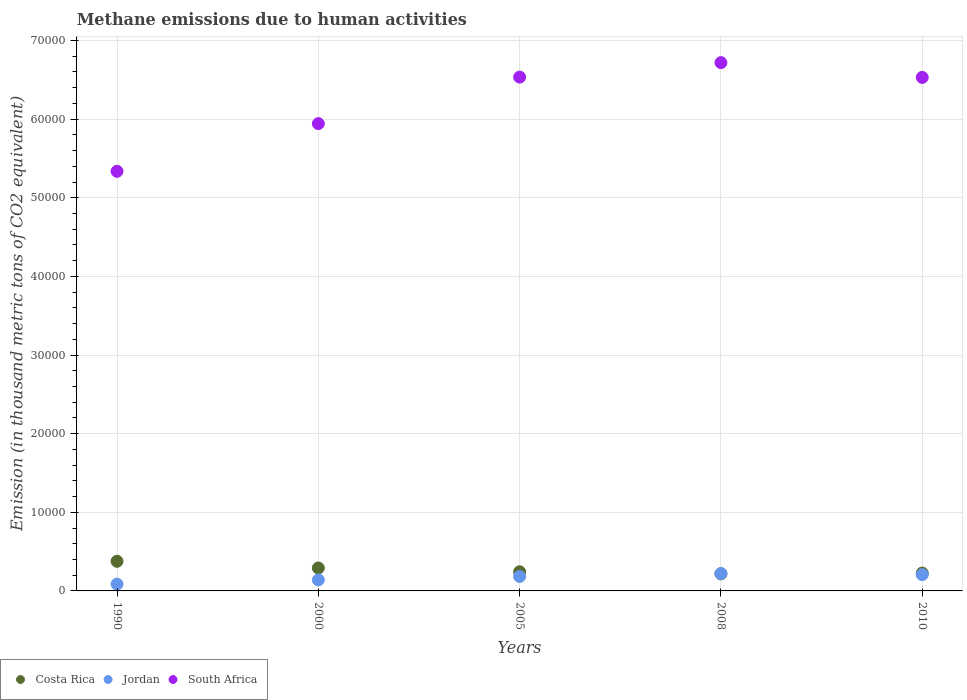How many different coloured dotlines are there?
Give a very brief answer. 3. What is the amount of methane emitted in Jordan in 2000?
Offer a terse response. 1401.8. Across all years, what is the maximum amount of methane emitted in Jordan?
Your answer should be very brief. 2204.6. Across all years, what is the minimum amount of methane emitted in Costa Rica?
Your answer should be compact. 2167.9. In which year was the amount of methane emitted in Jordan maximum?
Your answer should be very brief. 2008. In which year was the amount of methane emitted in Jordan minimum?
Offer a terse response. 1990. What is the total amount of methane emitted in Costa Rica in the graph?
Your answer should be compact. 1.36e+04. What is the difference between the amount of methane emitted in South Africa in 2000 and that in 2010?
Offer a very short reply. -5881.2. What is the difference between the amount of methane emitted in South Africa in 2005 and the amount of methane emitted in Jordan in 2010?
Give a very brief answer. 6.33e+04. What is the average amount of methane emitted in South Africa per year?
Provide a short and direct response. 6.21e+04. In the year 2000, what is the difference between the amount of methane emitted in Costa Rica and amount of methane emitted in Jordan?
Keep it short and to the point. 1515.1. In how many years, is the amount of methane emitted in Costa Rica greater than 68000 thousand metric tons?
Ensure brevity in your answer.  0. What is the ratio of the amount of methane emitted in South Africa in 2000 to that in 2010?
Your response must be concise. 0.91. What is the difference between the highest and the second highest amount of methane emitted in Costa Rica?
Your response must be concise. 851.6. What is the difference between the highest and the lowest amount of methane emitted in South Africa?
Your answer should be very brief. 1.38e+04. In how many years, is the amount of methane emitted in Jordan greater than the average amount of methane emitted in Jordan taken over all years?
Ensure brevity in your answer.  3. Is the sum of the amount of methane emitted in Jordan in 1990 and 2005 greater than the maximum amount of methane emitted in Costa Rica across all years?
Your response must be concise. No. Is the amount of methane emitted in Jordan strictly less than the amount of methane emitted in South Africa over the years?
Your answer should be compact. Yes. How many dotlines are there?
Provide a short and direct response. 3. Does the graph contain any zero values?
Give a very brief answer. No. Does the graph contain grids?
Keep it short and to the point. Yes. What is the title of the graph?
Your answer should be very brief. Methane emissions due to human activities. What is the label or title of the X-axis?
Offer a very short reply. Years. What is the label or title of the Y-axis?
Your answer should be very brief. Emission (in thousand metric tons of CO2 equivalent). What is the Emission (in thousand metric tons of CO2 equivalent) in Costa Rica in 1990?
Ensure brevity in your answer.  3768.5. What is the Emission (in thousand metric tons of CO2 equivalent) of Jordan in 1990?
Keep it short and to the point. 867.1. What is the Emission (in thousand metric tons of CO2 equivalent) in South Africa in 1990?
Provide a short and direct response. 5.34e+04. What is the Emission (in thousand metric tons of CO2 equivalent) in Costa Rica in 2000?
Provide a succinct answer. 2916.9. What is the Emission (in thousand metric tons of CO2 equivalent) of Jordan in 2000?
Ensure brevity in your answer.  1401.8. What is the Emission (in thousand metric tons of CO2 equivalent) of South Africa in 2000?
Your response must be concise. 5.94e+04. What is the Emission (in thousand metric tons of CO2 equivalent) in Costa Rica in 2005?
Make the answer very short. 2434.9. What is the Emission (in thousand metric tons of CO2 equivalent) in Jordan in 2005?
Your response must be concise. 1833.2. What is the Emission (in thousand metric tons of CO2 equivalent) of South Africa in 2005?
Your answer should be compact. 6.53e+04. What is the Emission (in thousand metric tons of CO2 equivalent) in Costa Rica in 2008?
Make the answer very short. 2167.9. What is the Emission (in thousand metric tons of CO2 equivalent) of Jordan in 2008?
Provide a short and direct response. 2204.6. What is the Emission (in thousand metric tons of CO2 equivalent) of South Africa in 2008?
Ensure brevity in your answer.  6.72e+04. What is the Emission (in thousand metric tons of CO2 equivalent) in Costa Rica in 2010?
Offer a terse response. 2273.7. What is the Emission (in thousand metric tons of CO2 equivalent) in Jordan in 2010?
Your answer should be very brief. 2072.1. What is the Emission (in thousand metric tons of CO2 equivalent) of South Africa in 2010?
Your answer should be compact. 6.53e+04. Across all years, what is the maximum Emission (in thousand metric tons of CO2 equivalent) of Costa Rica?
Keep it short and to the point. 3768.5. Across all years, what is the maximum Emission (in thousand metric tons of CO2 equivalent) in Jordan?
Provide a short and direct response. 2204.6. Across all years, what is the maximum Emission (in thousand metric tons of CO2 equivalent) in South Africa?
Give a very brief answer. 6.72e+04. Across all years, what is the minimum Emission (in thousand metric tons of CO2 equivalent) of Costa Rica?
Offer a terse response. 2167.9. Across all years, what is the minimum Emission (in thousand metric tons of CO2 equivalent) in Jordan?
Your answer should be very brief. 867.1. Across all years, what is the minimum Emission (in thousand metric tons of CO2 equivalent) in South Africa?
Ensure brevity in your answer.  5.34e+04. What is the total Emission (in thousand metric tons of CO2 equivalent) in Costa Rica in the graph?
Your answer should be very brief. 1.36e+04. What is the total Emission (in thousand metric tons of CO2 equivalent) of Jordan in the graph?
Provide a succinct answer. 8378.8. What is the total Emission (in thousand metric tons of CO2 equivalent) of South Africa in the graph?
Offer a very short reply. 3.11e+05. What is the difference between the Emission (in thousand metric tons of CO2 equivalent) in Costa Rica in 1990 and that in 2000?
Make the answer very short. 851.6. What is the difference between the Emission (in thousand metric tons of CO2 equivalent) of Jordan in 1990 and that in 2000?
Keep it short and to the point. -534.7. What is the difference between the Emission (in thousand metric tons of CO2 equivalent) of South Africa in 1990 and that in 2000?
Provide a short and direct response. -6061.3. What is the difference between the Emission (in thousand metric tons of CO2 equivalent) of Costa Rica in 1990 and that in 2005?
Give a very brief answer. 1333.6. What is the difference between the Emission (in thousand metric tons of CO2 equivalent) of Jordan in 1990 and that in 2005?
Ensure brevity in your answer.  -966.1. What is the difference between the Emission (in thousand metric tons of CO2 equivalent) of South Africa in 1990 and that in 2005?
Your response must be concise. -1.20e+04. What is the difference between the Emission (in thousand metric tons of CO2 equivalent) in Costa Rica in 1990 and that in 2008?
Your answer should be very brief. 1600.6. What is the difference between the Emission (in thousand metric tons of CO2 equivalent) in Jordan in 1990 and that in 2008?
Offer a very short reply. -1337.5. What is the difference between the Emission (in thousand metric tons of CO2 equivalent) in South Africa in 1990 and that in 2008?
Your answer should be very brief. -1.38e+04. What is the difference between the Emission (in thousand metric tons of CO2 equivalent) in Costa Rica in 1990 and that in 2010?
Keep it short and to the point. 1494.8. What is the difference between the Emission (in thousand metric tons of CO2 equivalent) of Jordan in 1990 and that in 2010?
Your answer should be compact. -1205. What is the difference between the Emission (in thousand metric tons of CO2 equivalent) in South Africa in 1990 and that in 2010?
Your answer should be very brief. -1.19e+04. What is the difference between the Emission (in thousand metric tons of CO2 equivalent) of Costa Rica in 2000 and that in 2005?
Your answer should be very brief. 482. What is the difference between the Emission (in thousand metric tons of CO2 equivalent) of Jordan in 2000 and that in 2005?
Your response must be concise. -431.4. What is the difference between the Emission (in thousand metric tons of CO2 equivalent) of South Africa in 2000 and that in 2005?
Provide a succinct answer. -5917.5. What is the difference between the Emission (in thousand metric tons of CO2 equivalent) of Costa Rica in 2000 and that in 2008?
Provide a short and direct response. 749. What is the difference between the Emission (in thousand metric tons of CO2 equivalent) of Jordan in 2000 and that in 2008?
Your answer should be very brief. -802.8. What is the difference between the Emission (in thousand metric tons of CO2 equivalent) in South Africa in 2000 and that in 2008?
Your answer should be compact. -7757.2. What is the difference between the Emission (in thousand metric tons of CO2 equivalent) in Costa Rica in 2000 and that in 2010?
Offer a very short reply. 643.2. What is the difference between the Emission (in thousand metric tons of CO2 equivalent) in Jordan in 2000 and that in 2010?
Your answer should be compact. -670.3. What is the difference between the Emission (in thousand metric tons of CO2 equivalent) of South Africa in 2000 and that in 2010?
Offer a terse response. -5881.2. What is the difference between the Emission (in thousand metric tons of CO2 equivalent) in Costa Rica in 2005 and that in 2008?
Offer a terse response. 267. What is the difference between the Emission (in thousand metric tons of CO2 equivalent) in Jordan in 2005 and that in 2008?
Your response must be concise. -371.4. What is the difference between the Emission (in thousand metric tons of CO2 equivalent) of South Africa in 2005 and that in 2008?
Your answer should be compact. -1839.7. What is the difference between the Emission (in thousand metric tons of CO2 equivalent) in Costa Rica in 2005 and that in 2010?
Offer a terse response. 161.2. What is the difference between the Emission (in thousand metric tons of CO2 equivalent) in Jordan in 2005 and that in 2010?
Your answer should be very brief. -238.9. What is the difference between the Emission (in thousand metric tons of CO2 equivalent) in South Africa in 2005 and that in 2010?
Give a very brief answer. 36.3. What is the difference between the Emission (in thousand metric tons of CO2 equivalent) in Costa Rica in 2008 and that in 2010?
Offer a terse response. -105.8. What is the difference between the Emission (in thousand metric tons of CO2 equivalent) of Jordan in 2008 and that in 2010?
Offer a very short reply. 132.5. What is the difference between the Emission (in thousand metric tons of CO2 equivalent) of South Africa in 2008 and that in 2010?
Your answer should be very brief. 1876. What is the difference between the Emission (in thousand metric tons of CO2 equivalent) in Costa Rica in 1990 and the Emission (in thousand metric tons of CO2 equivalent) in Jordan in 2000?
Provide a short and direct response. 2366.7. What is the difference between the Emission (in thousand metric tons of CO2 equivalent) in Costa Rica in 1990 and the Emission (in thousand metric tons of CO2 equivalent) in South Africa in 2000?
Your answer should be compact. -5.57e+04. What is the difference between the Emission (in thousand metric tons of CO2 equivalent) of Jordan in 1990 and the Emission (in thousand metric tons of CO2 equivalent) of South Africa in 2000?
Keep it short and to the point. -5.86e+04. What is the difference between the Emission (in thousand metric tons of CO2 equivalent) in Costa Rica in 1990 and the Emission (in thousand metric tons of CO2 equivalent) in Jordan in 2005?
Ensure brevity in your answer.  1935.3. What is the difference between the Emission (in thousand metric tons of CO2 equivalent) of Costa Rica in 1990 and the Emission (in thousand metric tons of CO2 equivalent) of South Africa in 2005?
Ensure brevity in your answer.  -6.16e+04. What is the difference between the Emission (in thousand metric tons of CO2 equivalent) in Jordan in 1990 and the Emission (in thousand metric tons of CO2 equivalent) in South Africa in 2005?
Ensure brevity in your answer.  -6.45e+04. What is the difference between the Emission (in thousand metric tons of CO2 equivalent) of Costa Rica in 1990 and the Emission (in thousand metric tons of CO2 equivalent) of Jordan in 2008?
Offer a terse response. 1563.9. What is the difference between the Emission (in thousand metric tons of CO2 equivalent) in Costa Rica in 1990 and the Emission (in thousand metric tons of CO2 equivalent) in South Africa in 2008?
Offer a very short reply. -6.34e+04. What is the difference between the Emission (in thousand metric tons of CO2 equivalent) of Jordan in 1990 and the Emission (in thousand metric tons of CO2 equivalent) of South Africa in 2008?
Ensure brevity in your answer.  -6.63e+04. What is the difference between the Emission (in thousand metric tons of CO2 equivalent) in Costa Rica in 1990 and the Emission (in thousand metric tons of CO2 equivalent) in Jordan in 2010?
Offer a terse response. 1696.4. What is the difference between the Emission (in thousand metric tons of CO2 equivalent) in Costa Rica in 1990 and the Emission (in thousand metric tons of CO2 equivalent) in South Africa in 2010?
Your answer should be very brief. -6.15e+04. What is the difference between the Emission (in thousand metric tons of CO2 equivalent) of Jordan in 1990 and the Emission (in thousand metric tons of CO2 equivalent) of South Africa in 2010?
Provide a short and direct response. -6.44e+04. What is the difference between the Emission (in thousand metric tons of CO2 equivalent) of Costa Rica in 2000 and the Emission (in thousand metric tons of CO2 equivalent) of Jordan in 2005?
Your response must be concise. 1083.7. What is the difference between the Emission (in thousand metric tons of CO2 equivalent) of Costa Rica in 2000 and the Emission (in thousand metric tons of CO2 equivalent) of South Africa in 2005?
Offer a terse response. -6.24e+04. What is the difference between the Emission (in thousand metric tons of CO2 equivalent) of Jordan in 2000 and the Emission (in thousand metric tons of CO2 equivalent) of South Africa in 2005?
Keep it short and to the point. -6.39e+04. What is the difference between the Emission (in thousand metric tons of CO2 equivalent) in Costa Rica in 2000 and the Emission (in thousand metric tons of CO2 equivalent) in Jordan in 2008?
Your response must be concise. 712.3. What is the difference between the Emission (in thousand metric tons of CO2 equivalent) in Costa Rica in 2000 and the Emission (in thousand metric tons of CO2 equivalent) in South Africa in 2008?
Ensure brevity in your answer.  -6.43e+04. What is the difference between the Emission (in thousand metric tons of CO2 equivalent) of Jordan in 2000 and the Emission (in thousand metric tons of CO2 equivalent) of South Africa in 2008?
Offer a terse response. -6.58e+04. What is the difference between the Emission (in thousand metric tons of CO2 equivalent) of Costa Rica in 2000 and the Emission (in thousand metric tons of CO2 equivalent) of Jordan in 2010?
Give a very brief answer. 844.8. What is the difference between the Emission (in thousand metric tons of CO2 equivalent) in Costa Rica in 2000 and the Emission (in thousand metric tons of CO2 equivalent) in South Africa in 2010?
Provide a short and direct response. -6.24e+04. What is the difference between the Emission (in thousand metric tons of CO2 equivalent) of Jordan in 2000 and the Emission (in thousand metric tons of CO2 equivalent) of South Africa in 2010?
Your answer should be very brief. -6.39e+04. What is the difference between the Emission (in thousand metric tons of CO2 equivalent) in Costa Rica in 2005 and the Emission (in thousand metric tons of CO2 equivalent) in Jordan in 2008?
Your answer should be very brief. 230.3. What is the difference between the Emission (in thousand metric tons of CO2 equivalent) in Costa Rica in 2005 and the Emission (in thousand metric tons of CO2 equivalent) in South Africa in 2008?
Provide a short and direct response. -6.48e+04. What is the difference between the Emission (in thousand metric tons of CO2 equivalent) in Jordan in 2005 and the Emission (in thousand metric tons of CO2 equivalent) in South Africa in 2008?
Your answer should be very brief. -6.54e+04. What is the difference between the Emission (in thousand metric tons of CO2 equivalent) of Costa Rica in 2005 and the Emission (in thousand metric tons of CO2 equivalent) of Jordan in 2010?
Offer a terse response. 362.8. What is the difference between the Emission (in thousand metric tons of CO2 equivalent) in Costa Rica in 2005 and the Emission (in thousand metric tons of CO2 equivalent) in South Africa in 2010?
Keep it short and to the point. -6.29e+04. What is the difference between the Emission (in thousand metric tons of CO2 equivalent) in Jordan in 2005 and the Emission (in thousand metric tons of CO2 equivalent) in South Africa in 2010?
Your answer should be compact. -6.35e+04. What is the difference between the Emission (in thousand metric tons of CO2 equivalent) of Costa Rica in 2008 and the Emission (in thousand metric tons of CO2 equivalent) of Jordan in 2010?
Your answer should be compact. 95.8. What is the difference between the Emission (in thousand metric tons of CO2 equivalent) in Costa Rica in 2008 and the Emission (in thousand metric tons of CO2 equivalent) in South Africa in 2010?
Give a very brief answer. -6.31e+04. What is the difference between the Emission (in thousand metric tons of CO2 equivalent) in Jordan in 2008 and the Emission (in thousand metric tons of CO2 equivalent) in South Africa in 2010?
Provide a short and direct response. -6.31e+04. What is the average Emission (in thousand metric tons of CO2 equivalent) in Costa Rica per year?
Your answer should be compact. 2712.38. What is the average Emission (in thousand metric tons of CO2 equivalent) in Jordan per year?
Make the answer very short. 1675.76. What is the average Emission (in thousand metric tons of CO2 equivalent) of South Africa per year?
Offer a very short reply. 6.21e+04. In the year 1990, what is the difference between the Emission (in thousand metric tons of CO2 equivalent) of Costa Rica and Emission (in thousand metric tons of CO2 equivalent) of Jordan?
Offer a terse response. 2901.4. In the year 1990, what is the difference between the Emission (in thousand metric tons of CO2 equivalent) in Costa Rica and Emission (in thousand metric tons of CO2 equivalent) in South Africa?
Your answer should be very brief. -4.96e+04. In the year 1990, what is the difference between the Emission (in thousand metric tons of CO2 equivalent) in Jordan and Emission (in thousand metric tons of CO2 equivalent) in South Africa?
Offer a very short reply. -5.25e+04. In the year 2000, what is the difference between the Emission (in thousand metric tons of CO2 equivalent) in Costa Rica and Emission (in thousand metric tons of CO2 equivalent) in Jordan?
Your answer should be compact. 1515.1. In the year 2000, what is the difference between the Emission (in thousand metric tons of CO2 equivalent) of Costa Rica and Emission (in thousand metric tons of CO2 equivalent) of South Africa?
Keep it short and to the point. -5.65e+04. In the year 2000, what is the difference between the Emission (in thousand metric tons of CO2 equivalent) of Jordan and Emission (in thousand metric tons of CO2 equivalent) of South Africa?
Provide a succinct answer. -5.80e+04. In the year 2005, what is the difference between the Emission (in thousand metric tons of CO2 equivalent) in Costa Rica and Emission (in thousand metric tons of CO2 equivalent) in Jordan?
Make the answer very short. 601.7. In the year 2005, what is the difference between the Emission (in thousand metric tons of CO2 equivalent) in Costa Rica and Emission (in thousand metric tons of CO2 equivalent) in South Africa?
Ensure brevity in your answer.  -6.29e+04. In the year 2005, what is the difference between the Emission (in thousand metric tons of CO2 equivalent) of Jordan and Emission (in thousand metric tons of CO2 equivalent) of South Africa?
Your response must be concise. -6.35e+04. In the year 2008, what is the difference between the Emission (in thousand metric tons of CO2 equivalent) in Costa Rica and Emission (in thousand metric tons of CO2 equivalent) in Jordan?
Provide a succinct answer. -36.7. In the year 2008, what is the difference between the Emission (in thousand metric tons of CO2 equivalent) in Costa Rica and Emission (in thousand metric tons of CO2 equivalent) in South Africa?
Offer a terse response. -6.50e+04. In the year 2008, what is the difference between the Emission (in thousand metric tons of CO2 equivalent) in Jordan and Emission (in thousand metric tons of CO2 equivalent) in South Africa?
Provide a short and direct response. -6.50e+04. In the year 2010, what is the difference between the Emission (in thousand metric tons of CO2 equivalent) of Costa Rica and Emission (in thousand metric tons of CO2 equivalent) of Jordan?
Offer a very short reply. 201.6. In the year 2010, what is the difference between the Emission (in thousand metric tons of CO2 equivalent) in Costa Rica and Emission (in thousand metric tons of CO2 equivalent) in South Africa?
Provide a succinct answer. -6.30e+04. In the year 2010, what is the difference between the Emission (in thousand metric tons of CO2 equivalent) of Jordan and Emission (in thousand metric tons of CO2 equivalent) of South Africa?
Make the answer very short. -6.32e+04. What is the ratio of the Emission (in thousand metric tons of CO2 equivalent) in Costa Rica in 1990 to that in 2000?
Keep it short and to the point. 1.29. What is the ratio of the Emission (in thousand metric tons of CO2 equivalent) in Jordan in 1990 to that in 2000?
Your answer should be very brief. 0.62. What is the ratio of the Emission (in thousand metric tons of CO2 equivalent) in South Africa in 1990 to that in 2000?
Your response must be concise. 0.9. What is the ratio of the Emission (in thousand metric tons of CO2 equivalent) in Costa Rica in 1990 to that in 2005?
Provide a succinct answer. 1.55. What is the ratio of the Emission (in thousand metric tons of CO2 equivalent) in Jordan in 1990 to that in 2005?
Your answer should be compact. 0.47. What is the ratio of the Emission (in thousand metric tons of CO2 equivalent) in South Africa in 1990 to that in 2005?
Offer a very short reply. 0.82. What is the ratio of the Emission (in thousand metric tons of CO2 equivalent) in Costa Rica in 1990 to that in 2008?
Give a very brief answer. 1.74. What is the ratio of the Emission (in thousand metric tons of CO2 equivalent) of Jordan in 1990 to that in 2008?
Offer a terse response. 0.39. What is the ratio of the Emission (in thousand metric tons of CO2 equivalent) in South Africa in 1990 to that in 2008?
Offer a terse response. 0.79. What is the ratio of the Emission (in thousand metric tons of CO2 equivalent) of Costa Rica in 1990 to that in 2010?
Ensure brevity in your answer.  1.66. What is the ratio of the Emission (in thousand metric tons of CO2 equivalent) of Jordan in 1990 to that in 2010?
Give a very brief answer. 0.42. What is the ratio of the Emission (in thousand metric tons of CO2 equivalent) of South Africa in 1990 to that in 2010?
Keep it short and to the point. 0.82. What is the ratio of the Emission (in thousand metric tons of CO2 equivalent) of Costa Rica in 2000 to that in 2005?
Provide a succinct answer. 1.2. What is the ratio of the Emission (in thousand metric tons of CO2 equivalent) in Jordan in 2000 to that in 2005?
Ensure brevity in your answer.  0.76. What is the ratio of the Emission (in thousand metric tons of CO2 equivalent) in South Africa in 2000 to that in 2005?
Make the answer very short. 0.91. What is the ratio of the Emission (in thousand metric tons of CO2 equivalent) of Costa Rica in 2000 to that in 2008?
Your response must be concise. 1.35. What is the ratio of the Emission (in thousand metric tons of CO2 equivalent) in Jordan in 2000 to that in 2008?
Ensure brevity in your answer.  0.64. What is the ratio of the Emission (in thousand metric tons of CO2 equivalent) in South Africa in 2000 to that in 2008?
Your response must be concise. 0.88. What is the ratio of the Emission (in thousand metric tons of CO2 equivalent) of Costa Rica in 2000 to that in 2010?
Ensure brevity in your answer.  1.28. What is the ratio of the Emission (in thousand metric tons of CO2 equivalent) of Jordan in 2000 to that in 2010?
Your answer should be very brief. 0.68. What is the ratio of the Emission (in thousand metric tons of CO2 equivalent) in South Africa in 2000 to that in 2010?
Ensure brevity in your answer.  0.91. What is the ratio of the Emission (in thousand metric tons of CO2 equivalent) in Costa Rica in 2005 to that in 2008?
Your answer should be very brief. 1.12. What is the ratio of the Emission (in thousand metric tons of CO2 equivalent) in Jordan in 2005 to that in 2008?
Provide a succinct answer. 0.83. What is the ratio of the Emission (in thousand metric tons of CO2 equivalent) of South Africa in 2005 to that in 2008?
Offer a terse response. 0.97. What is the ratio of the Emission (in thousand metric tons of CO2 equivalent) of Costa Rica in 2005 to that in 2010?
Offer a terse response. 1.07. What is the ratio of the Emission (in thousand metric tons of CO2 equivalent) of Jordan in 2005 to that in 2010?
Make the answer very short. 0.88. What is the ratio of the Emission (in thousand metric tons of CO2 equivalent) of South Africa in 2005 to that in 2010?
Make the answer very short. 1. What is the ratio of the Emission (in thousand metric tons of CO2 equivalent) of Costa Rica in 2008 to that in 2010?
Give a very brief answer. 0.95. What is the ratio of the Emission (in thousand metric tons of CO2 equivalent) of Jordan in 2008 to that in 2010?
Provide a succinct answer. 1.06. What is the ratio of the Emission (in thousand metric tons of CO2 equivalent) in South Africa in 2008 to that in 2010?
Ensure brevity in your answer.  1.03. What is the difference between the highest and the second highest Emission (in thousand metric tons of CO2 equivalent) in Costa Rica?
Your response must be concise. 851.6. What is the difference between the highest and the second highest Emission (in thousand metric tons of CO2 equivalent) in Jordan?
Give a very brief answer. 132.5. What is the difference between the highest and the second highest Emission (in thousand metric tons of CO2 equivalent) of South Africa?
Provide a short and direct response. 1839.7. What is the difference between the highest and the lowest Emission (in thousand metric tons of CO2 equivalent) of Costa Rica?
Provide a short and direct response. 1600.6. What is the difference between the highest and the lowest Emission (in thousand metric tons of CO2 equivalent) in Jordan?
Keep it short and to the point. 1337.5. What is the difference between the highest and the lowest Emission (in thousand metric tons of CO2 equivalent) in South Africa?
Your answer should be very brief. 1.38e+04. 